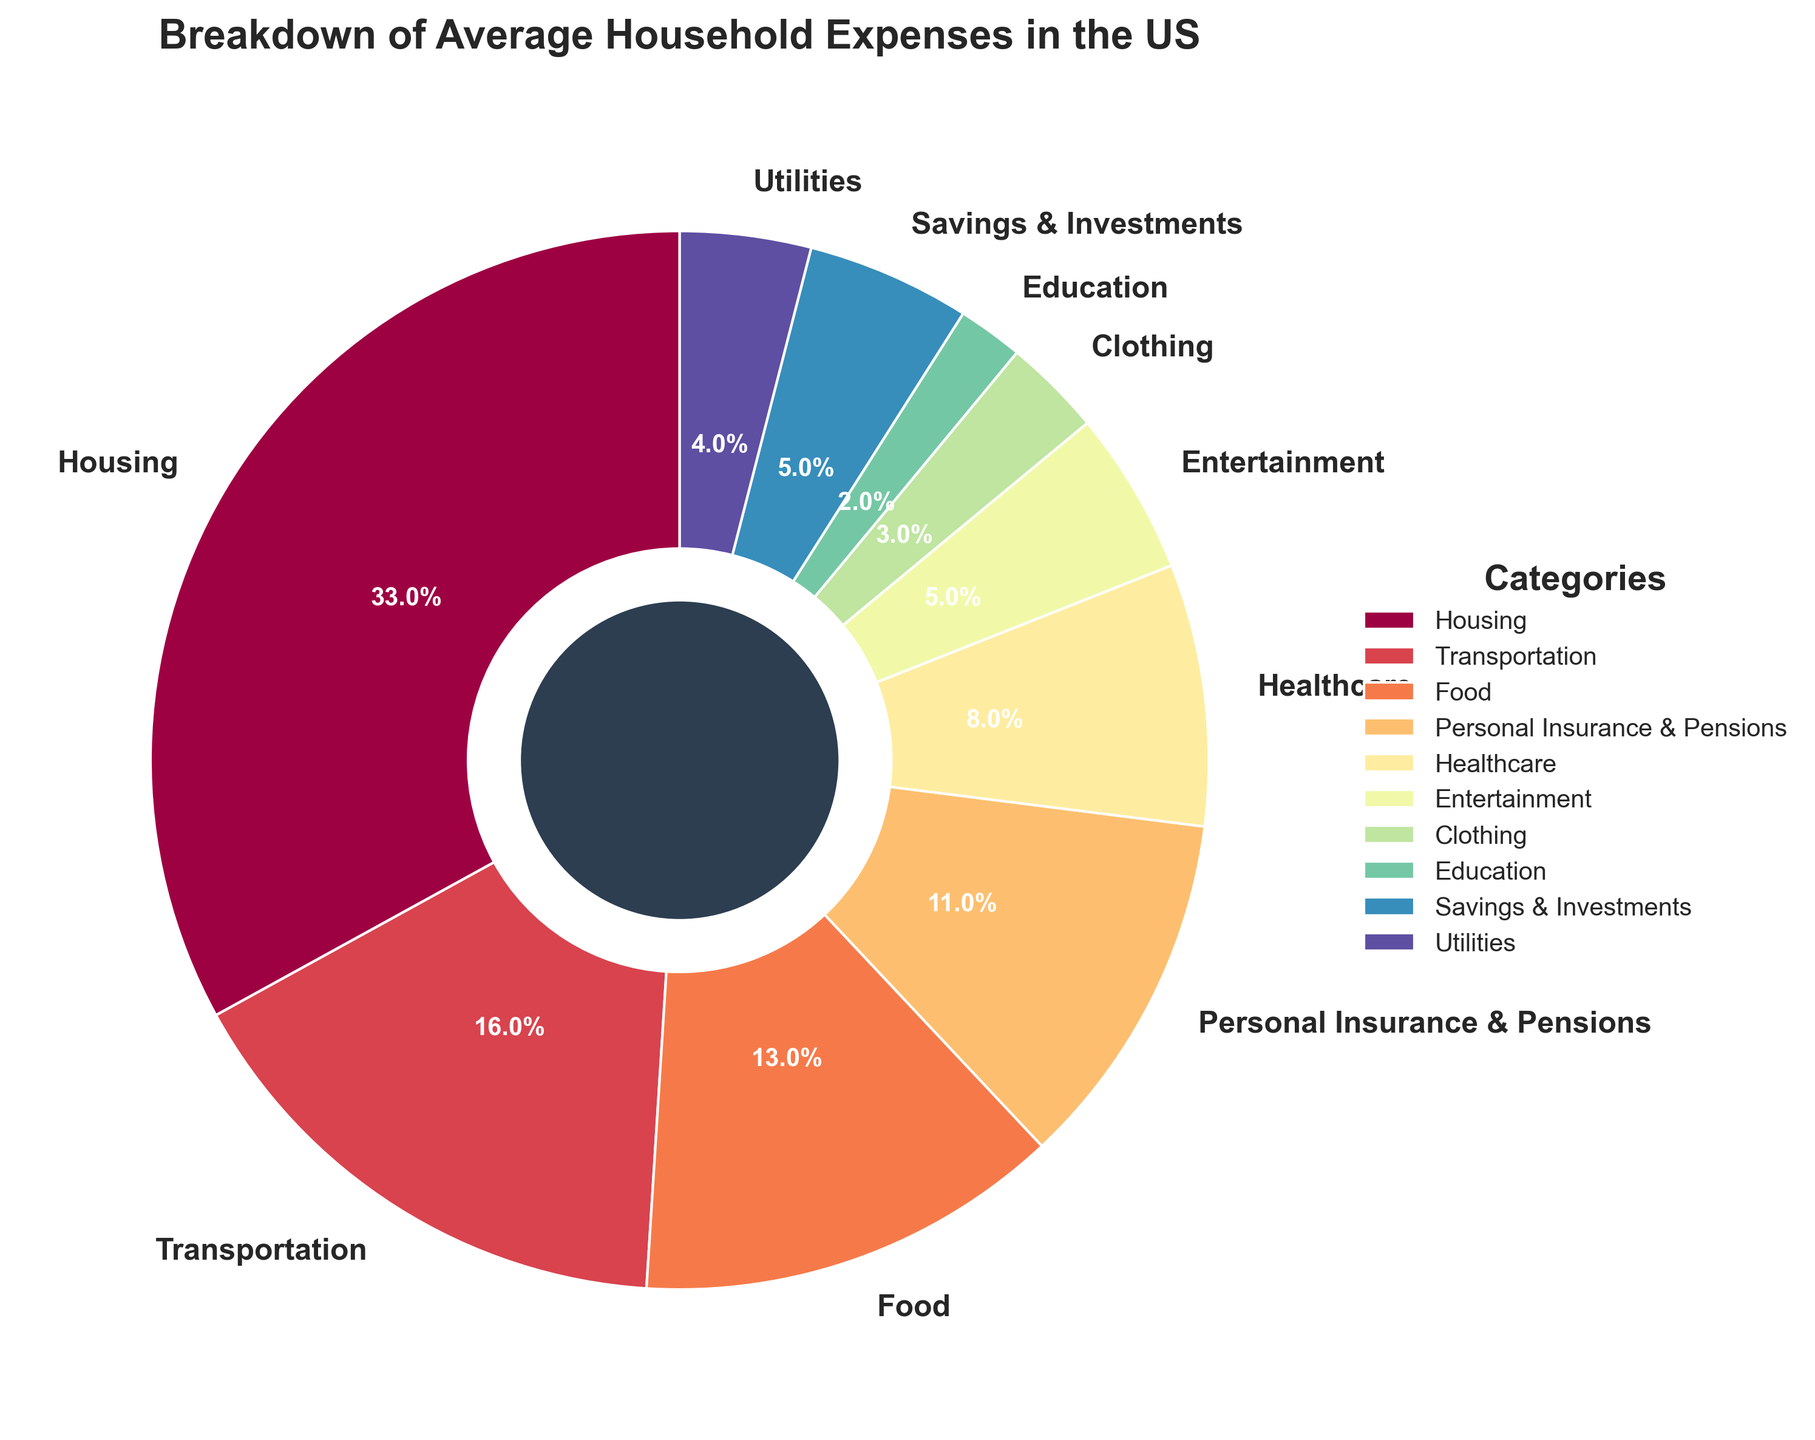Which category has the largest percentage of average household expenses? By looking at the pie chart, we can see that the largest wedge represents the Housing category.
Answer: Housing What's the combined percentage of expenses for Food and Transportation? By adding the percentages of Food (13%) and Transportation (16%), we get 13 + 16 = 29%.
Answer: 29% Which categories together account for more than 50% of the average household expenses? We sum the percentages starting from the largest until we surpass 50%. Housing (33%) + Transportation (16%) = 49%, including Food (13%) makes 62%, so Housing, Transportation, and Food together account for 62%.
Answer: Housing, Transportation, Food How much larger is the percentage of Healthcare expenses compared to Clothing expenses? Healthcare is 8%, and Clothing is 3%. The difference is 8 - 3 = 5%.
Answer: 5% What is the percentage difference between the expenses on Entertainment and Education? Entertainment accounts for 5%, and Education accounts for 2%. The difference is 5 - 2 = 3%.
Answer: 3% What proportion of the expenses is on categories labeled with a percentage between 3% and 5%? Within this range, the categories are Clothing (3%), Utilities (4%), Savings & Investments (5%), and Entertainment (5%). Adding these percentages gives 3 + 4 + 5 + 5 = 17%.
Answer: 17% Which category has the smallest percentage of average household expenses? The smallest wedge on the pie chart corresponds to Education, which is 2%.
Answer: Education How does the percentage of Personal Insurance & Pensions compare to that of Healthcare? Personal Insurance & Pensions account for 11%, while Healthcare accounts for 8%. Comparing them, 11% is larger than 8%.
Answer: Personal Insurance & Pensions is larger If we combine expenses on Transportation, Food, and Entertainment, what percentage of the average household expenses does it represent? Adding the percentages for Transportation (16%), Food (13%), and Entertainment (5%) gives us 16 + 13 + 5 = 34%.
Answer: 34% Is the proportion of Housing expenses greater than the combined proportion of Utilities and Savings & Investments? Housing expenses are 33%, while Utilities (4%) and Savings & Investments (5%) together add up to 4 + 5 = 9%. Comparing the two, 33% is greater than 9%.
Answer: Yes 